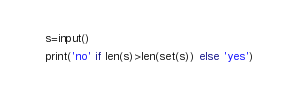<code> <loc_0><loc_0><loc_500><loc_500><_Python_>s=input()
print('no' if len(s)>len(set(s)) else 'yes')</code> 